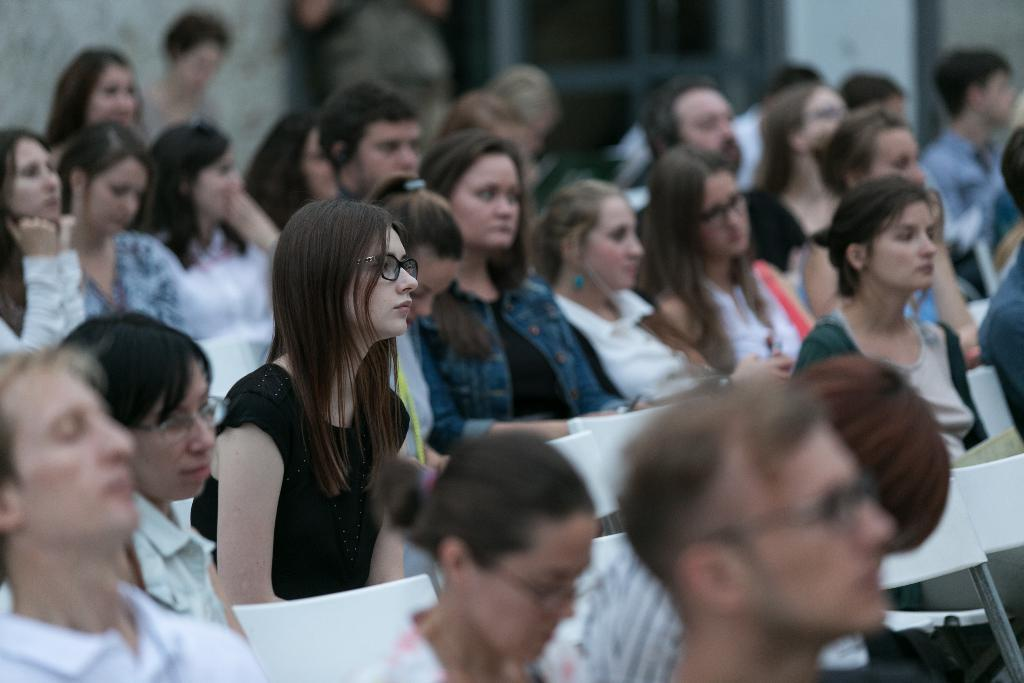How many people are in the image? There is a group of people in the image. What are the people sitting on? The people are sitting on white chairs. What can be seen in the background of the image? There is a building in the background of the image. What is the purpose of the door visible in the image? The door is likely used for entering or exiting the building in the background. What type of can is being used by the people in the image? There is no can present in the image; the people are sitting on white chairs. What type of plane can be seen flying in the background of the image? There is no plane visible in the image; the background features a building. 